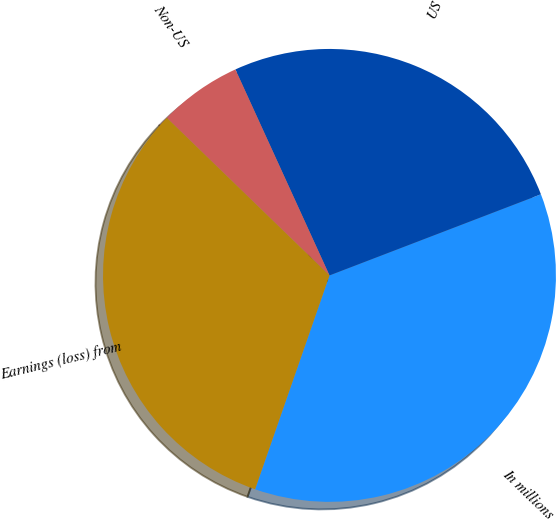<chart> <loc_0><loc_0><loc_500><loc_500><pie_chart><fcel>In millions<fcel>US<fcel>Non-US<fcel>Earnings (loss) from<nl><fcel>36.16%<fcel>25.99%<fcel>5.93%<fcel>31.92%<nl></chart> 